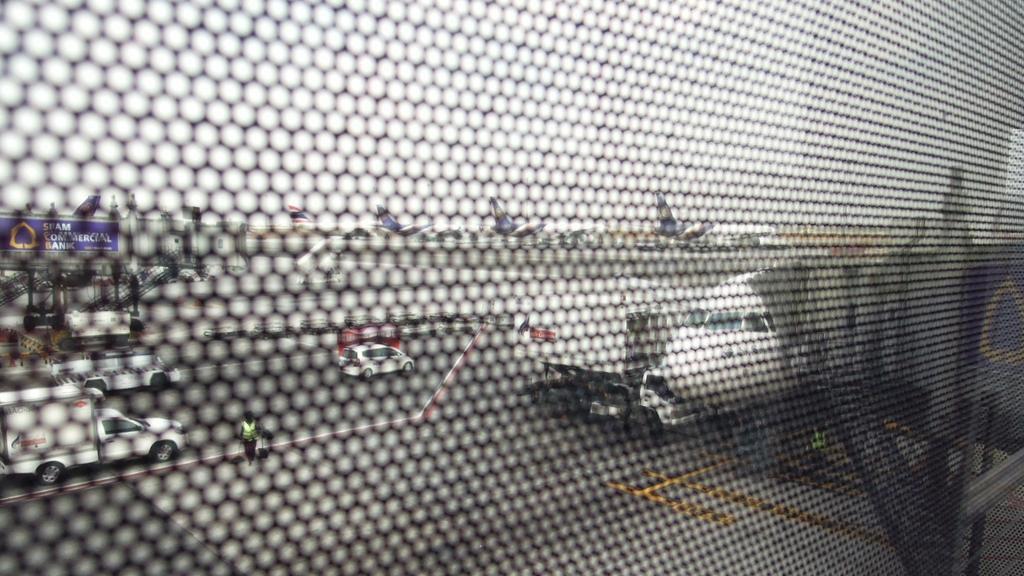Can you describe this image briefly? In the foreground of the image there is a net. In the background of the image there are aeroplanes,cars. 